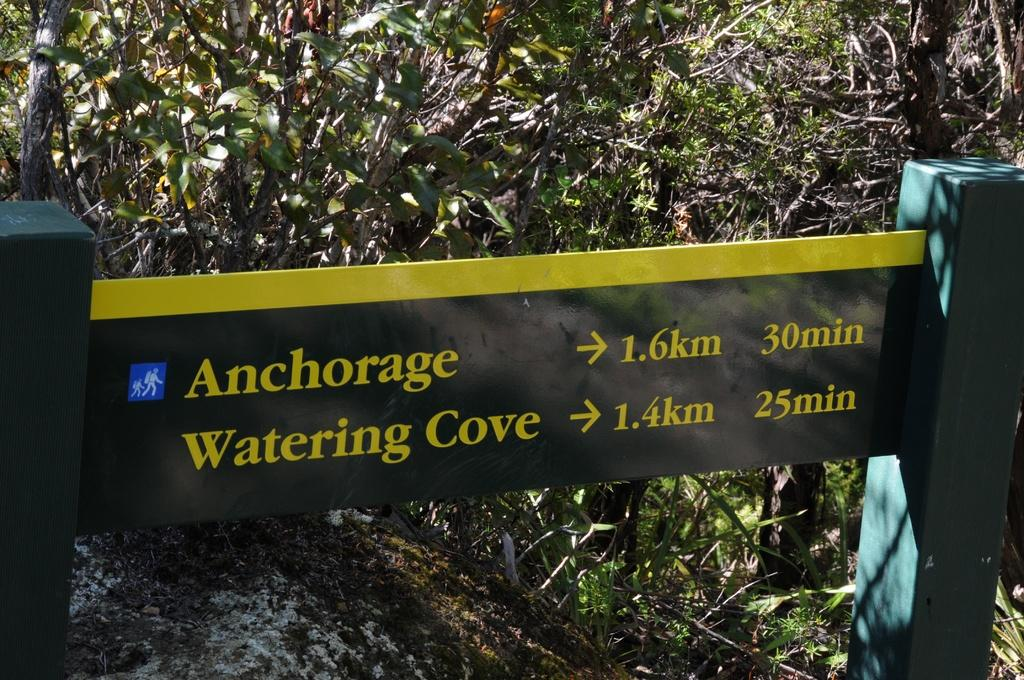What is the main object in the image? There is a direction sign board in the image. What can be seen in the background of the image? There are trees in the background of the image. What type of lip balm is recommended on the direction sign board? There is no lip balm mentioned or depicted on the direction sign board in the image. 